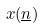Convert formula to latex. <formula><loc_0><loc_0><loc_500><loc_500>x ( \underline { n } )</formula> 